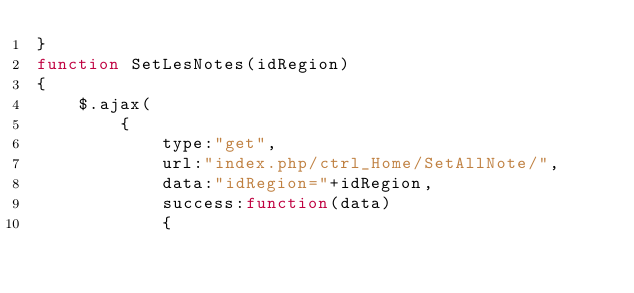<code> <loc_0><loc_0><loc_500><loc_500><_JavaScript_>}
function SetLesNotes(idRegion)
{
    $.ajax(
        {
            type:"get",
            url:"index.php/ctrl_Home/SetAllNote/",
            data:"idRegion="+idRegion,
            success:function(data)
            {</code> 